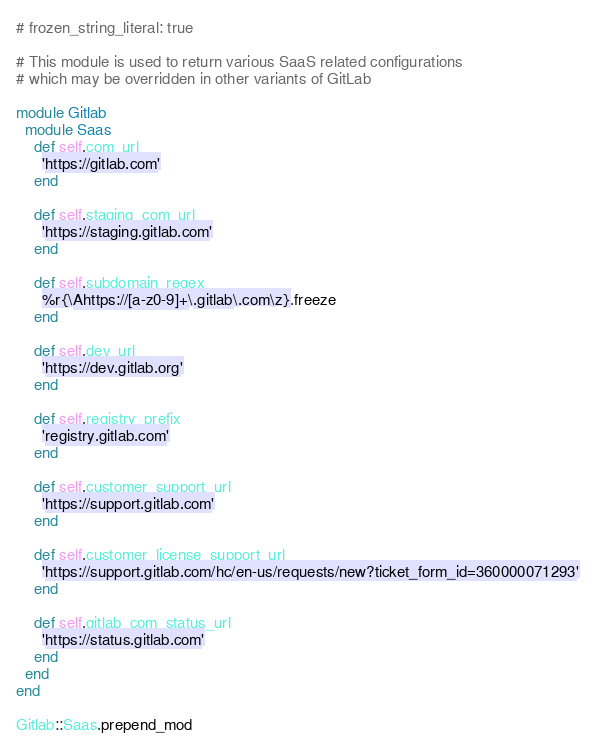Convert code to text. <code><loc_0><loc_0><loc_500><loc_500><_Ruby_># frozen_string_literal: true

# This module is used to return various SaaS related configurations
# which may be overridden in other variants of GitLab

module Gitlab
  module Saas
    def self.com_url
      'https://gitlab.com'
    end

    def self.staging_com_url
      'https://staging.gitlab.com'
    end

    def self.subdomain_regex
      %r{\Ahttps://[a-z0-9]+\.gitlab\.com\z}.freeze
    end

    def self.dev_url
      'https://dev.gitlab.org'
    end

    def self.registry_prefix
      'registry.gitlab.com'
    end

    def self.customer_support_url
      'https://support.gitlab.com'
    end

    def self.customer_license_support_url
      'https://support.gitlab.com/hc/en-us/requests/new?ticket_form_id=360000071293'
    end

    def self.gitlab_com_status_url
      'https://status.gitlab.com'
    end
  end
end

Gitlab::Saas.prepend_mod
</code> 